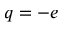Convert formula to latex. <formula><loc_0><loc_0><loc_500><loc_500>q = - e</formula> 